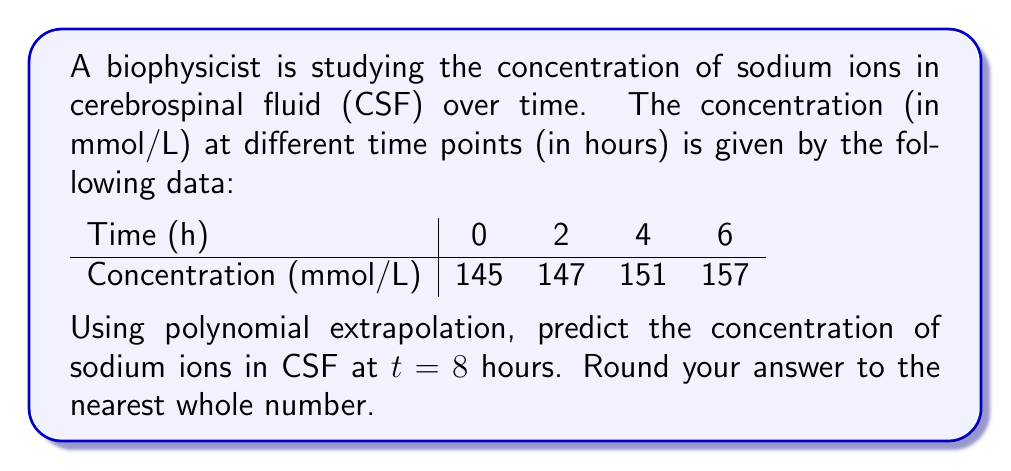Could you help me with this problem? To predict the concentration at t = 8 hours using polynomial extrapolation, we'll follow these steps:

1. Find the polynomial that fits the given data points.
2. Use the polynomial to extrapolate the concentration at t = 8.

Step 1: Finding the polynomial
We'll use Lagrange interpolation to find the polynomial. The Lagrange polynomial is given by:

$$ P(x) = \sum_{i=0}^{n} y_i \prod_{j \neq i} \frac{x - x_j}{x_i - x_j} $$

Where $(x_i, y_i)$ are the data points.

Calculating the terms:

$$ L_0(x) = \frac{(x-2)(x-4)(x-6)}{(0-2)(0-4)(0-6)} = \frac{x^3 - 12x^2 + 44x - 48}{48} $$
$$ L_1(x) = \frac{(x-0)(x-4)(x-6)}{(2-0)(2-4)(2-6)} = -\frac{x^3 - 10x^2 + 24x}{16} $$
$$ L_2(x) = \frac{(x-0)(x-2)(x-6)}{(4-0)(4-2)(4-6)} = \frac{x^3 - 8x^2 + 12x}{16} $$
$$ L_3(x) = \frac{(x-0)(x-2)(x-4)}{(6-0)(6-2)(6-4)} = -\frac{x^3 - 6x^2 + 8x}{48} $$

The polynomial is:

$$ P(x) = 145L_0(x) + 147L_1(x) + 151L_2(x) + 157L_3(x) $$

Simplifying:

$$ P(x) = 0.1667x^3 - 0.5x^2 + 2.3333x + 145 $$

Step 2: Extrapolating to t = 8
Substitute x = 8 into the polynomial:

$$ P(8) = 0.1667(8^3) - 0.5(8^2) + 2.3333(8) + 145 $$
$$ = 0.1667(512) - 0.5(64) + 2.3333(8) + 145 $$
$$ = 85.3504 - 32 + 18.6664 + 145 $$
$$ = 217.0168 $$

Rounding to the nearest whole number: 217 mmol/L
Answer: 217 mmol/L 